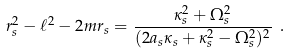<formula> <loc_0><loc_0><loc_500><loc_500>r _ { s } ^ { 2 } - \ell ^ { 2 } - 2 m r _ { s } = \frac { \kappa _ { s } ^ { 2 } + \Omega _ { s } ^ { 2 } } { ( 2 a _ { s } \kappa _ { s } + \kappa _ { s } ^ { 2 } - \Omega _ { s } ^ { 2 } ) ^ { 2 } } \ .</formula> 